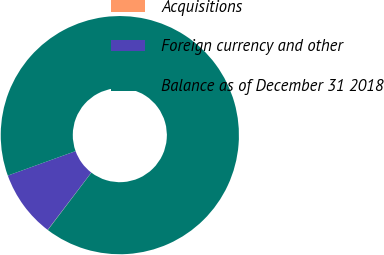<chart> <loc_0><loc_0><loc_500><loc_500><pie_chart><fcel>Acquisitions<fcel>Foreign currency and other<fcel>Balance as of December 31 2018<nl><fcel>0.04%<fcel>9.12%<fcel>90.85%<nl></chart> 